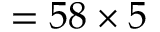Convert formula to latex. <formula><loc_0><loc_0><loc_500><loc_500>= 5 8 \times 5</formula> 